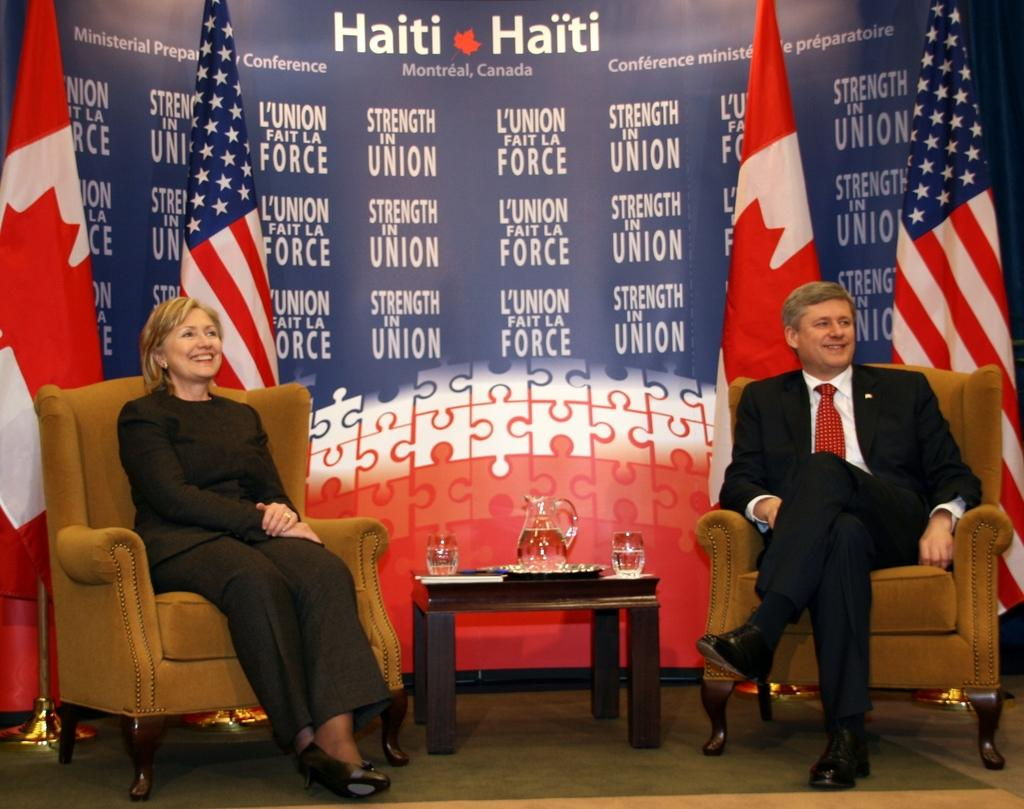How many people are in the image? There are two people in the image, a man and a woman. What are the man and woman doing in the image? Both the man and woman are sitting on chairs. What is present on the table in front of them? There is a water jug on the table. What can be seen in the background of the image? Flags are visible in the background of the image. What is the weight of the ship visible in the image? There is no ship present in the image; it features a man and a woman sitting on chairs with a water jug on a table and flags in the background. 